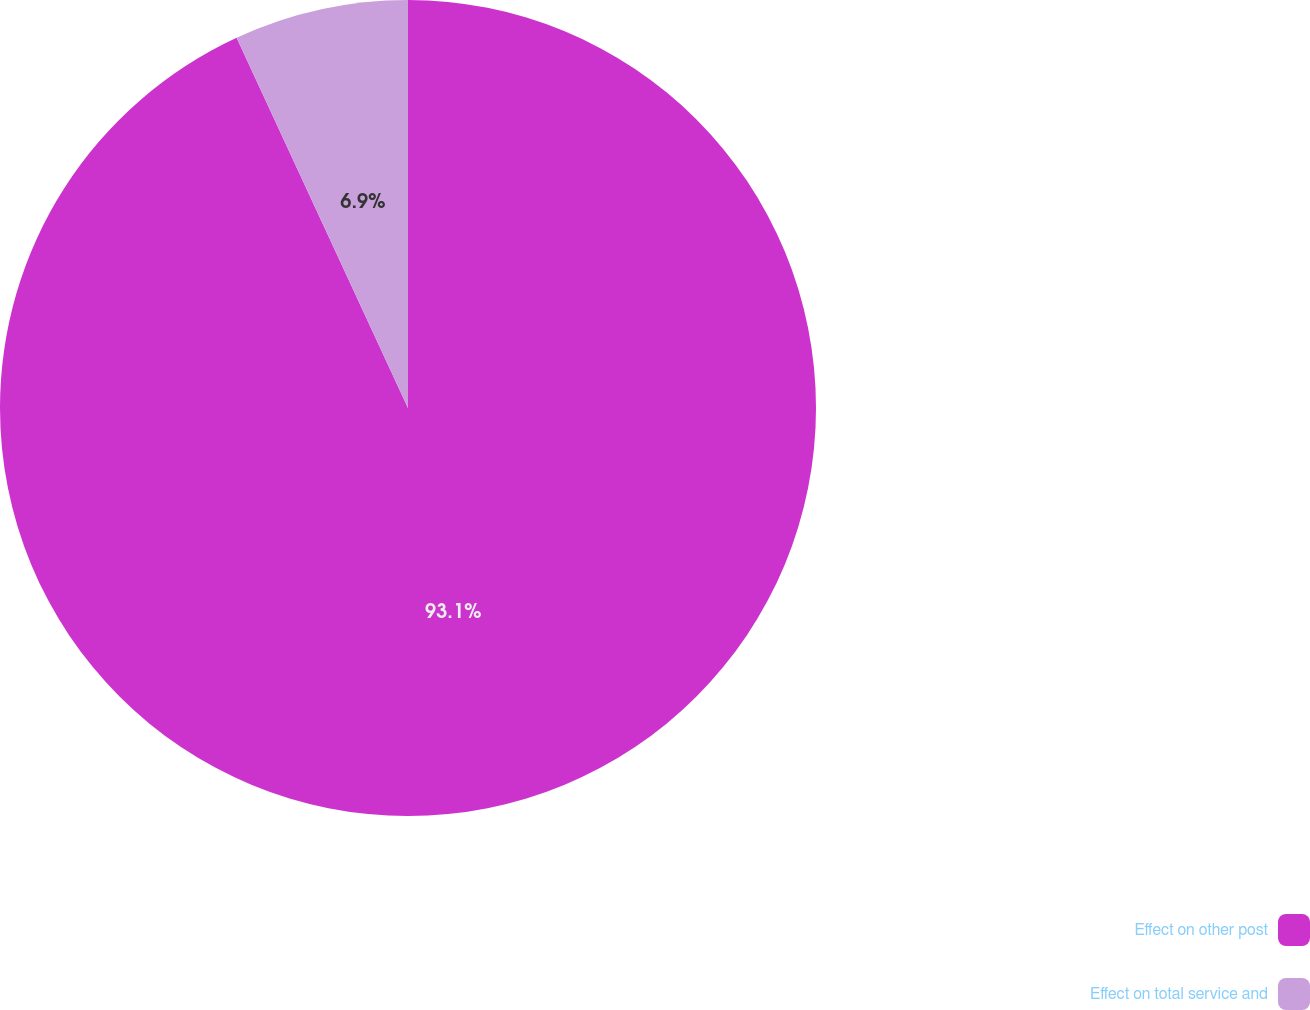Convert chart to OTSL. <chart><loc_0><loc_0><loc_500><loc_500><pie_chart><fcel>Effect on other post<fcel>Effect on total service and<nl><fcel>93.1%<fcel>6.9%<nl></chart> 